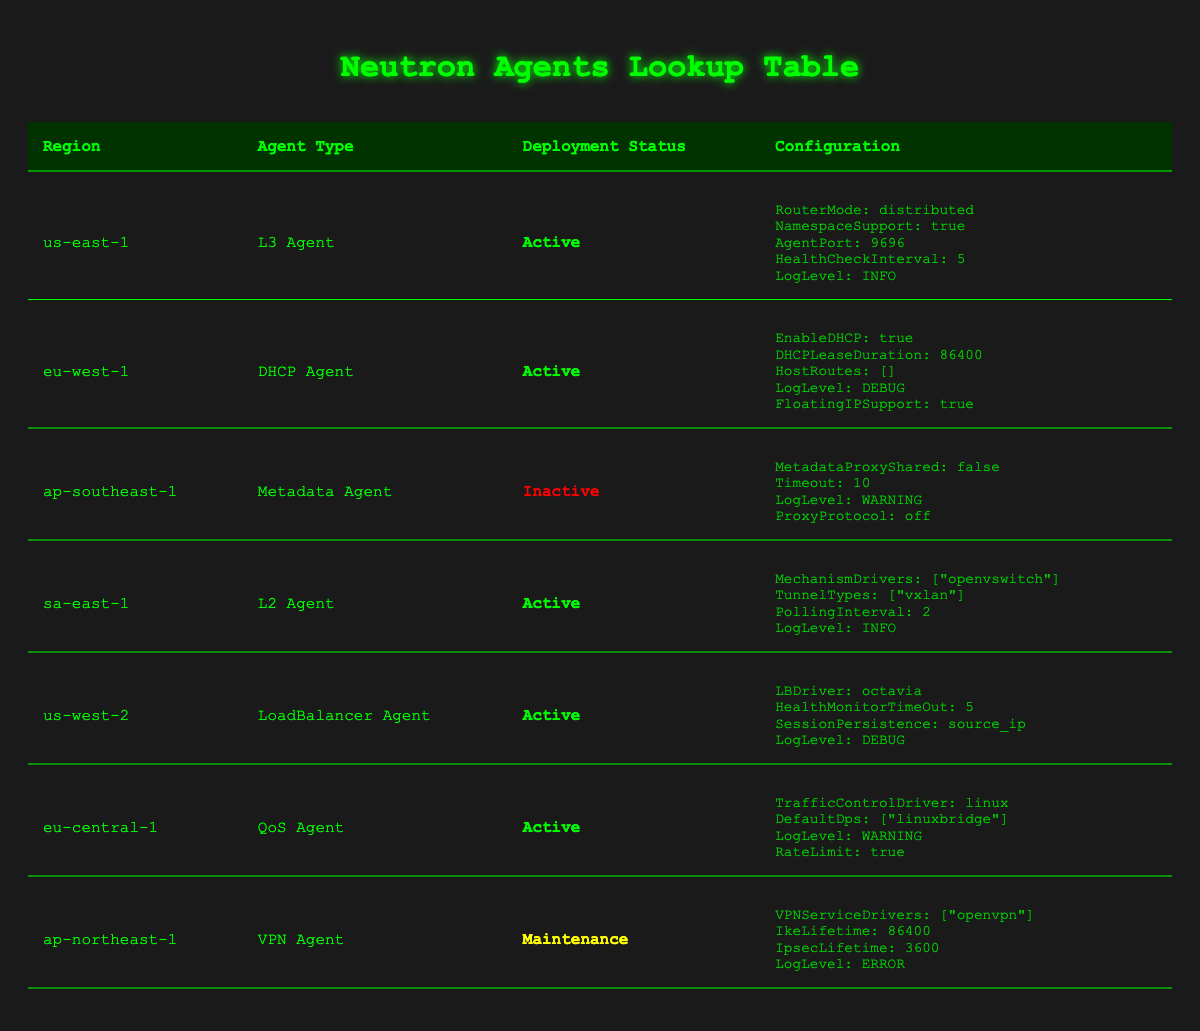What types of Neutron agents are deployed in the us-east-1 region? According to the table, the Neutron agents deployed in the us-east-1 region is of type "L3 Agent".
Answer: L3 Agent Which region has an inactive Neutron agent? The table indicates that the ap-southeast-1 region has a Neutron agent of type "Metadata Agent" with a deployment status of "Inactive".
Answer: ap-southeast-1 How many Neutron agents are currently active across all regions? By reviewing the table, there are five Neutron agents with the status "Active": L3 Agent (us-east-1), DHCP Agent (eu-west-1), L2 Agent (sa-east-1), LoadBalancer Agent (us-west-2), and QoS Agent (eu-central-1). Thus, the count is 5.
Answer: 5 Is the QoS Agent in the eu-central-1 region configured to support rate limiting? The table shows that the QoS Agent in the eu-central-1 region has "RateLimit" set to true in its configuration.
Answer: Yes In which regions are the Neutron agents in maintenance mode? The table indicates that only the ap-northeast-1 region has a Neutron agent of type "VPN Agent" with a deployment status of "Maintenance".
Answer: ap-northeast-1 What is the common log level set for active Neutron agents? Analyzing the log levels of all active Neutron agents, the ones in us-east-1, sa-east-1, us-west-2, and eu-central-1 have "INFO" or "DEBUG" levels. Therefore, there is not a single common log level among them.
Answer: No common log level How many different types of agents are deployed across regions? The table lists the following types of Neutron agents: L3 Agent, DHCP Agent, Metadata Agent, L2 Agent, LoadBalancer Agent, QoS Agent, and VPN Agent, making a total of 7 types present across various regions.
Answer: 7 What is the configuration setting for the AgentPort in the us-east-1 region? The configuration for the L3 Agent in the us-east-1 region specifies "AgentPort" as 9696.
Answer: 9696 How does the deployment status of the VPN Agent in the ap-northeast-1 region compare to other agents? The deployment status of the VPN Agent in the ap-northeast-1 region is "Maintenance", which is different from the majority of agents that are active, indicating that it is currently not fully operational compared to the others.
Answer: It is in Maintenance mode 